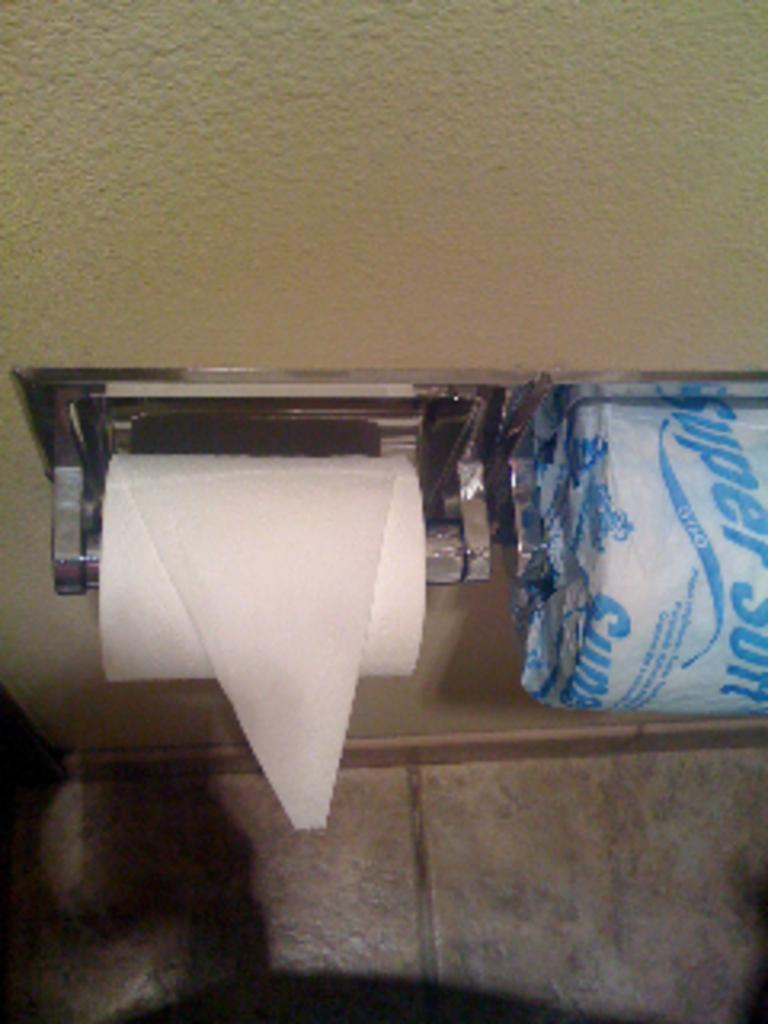<image>
Create a compact narrative representing the image presented. Two rolls of toilet paper, one of them with the words super soft 